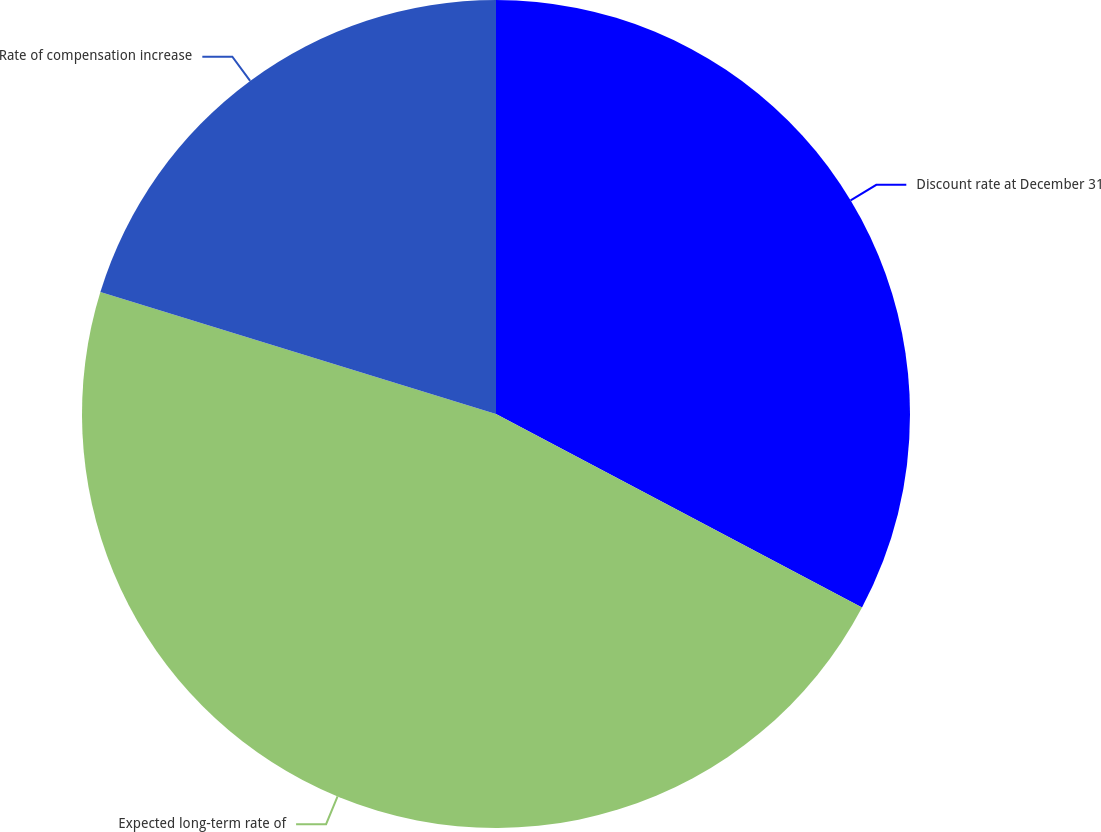Convert chart. <chart><loc_0><loc_0><loc_500><loc_500><pie_chart><fcel>Discount rate at December 31<fcel>Expected long-term rate of<fcel>Rate of compensation increase<nl><fcel>32.74%<fcel>47.02%<fcel>20.24%<nl></chart> 